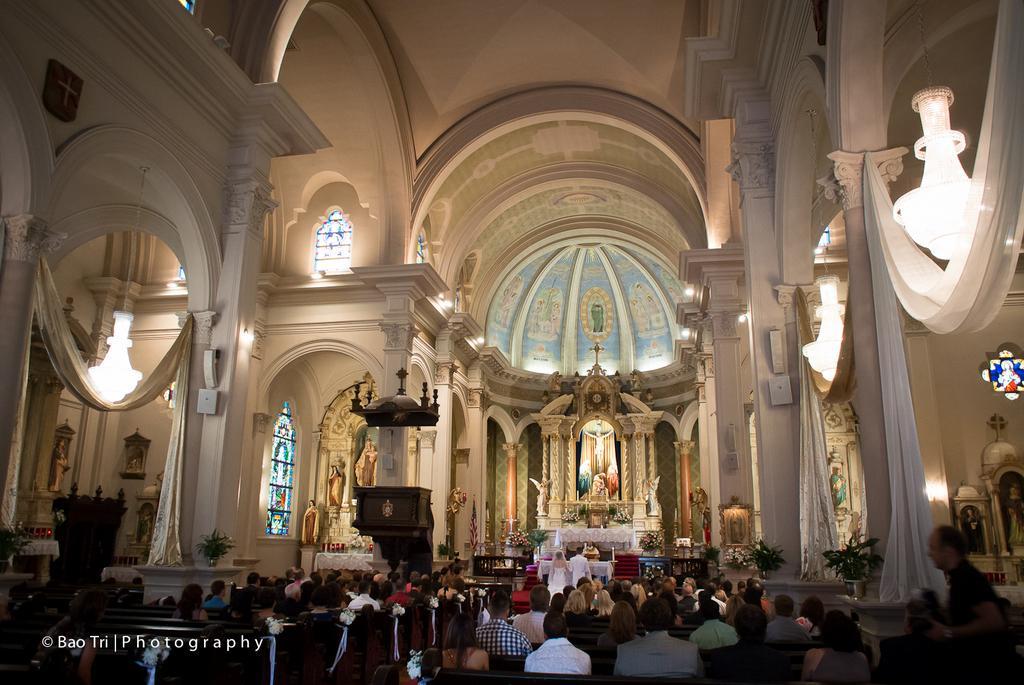Can you describe this image briefly? This image is of a church. At the bottom of the image there are many people sitting on bench. At the left side bottom of the image there is text printed. At the center of the image there is a god's idol. At the top of the image there is roof. At the left side of the image there are curtains to the walls. 